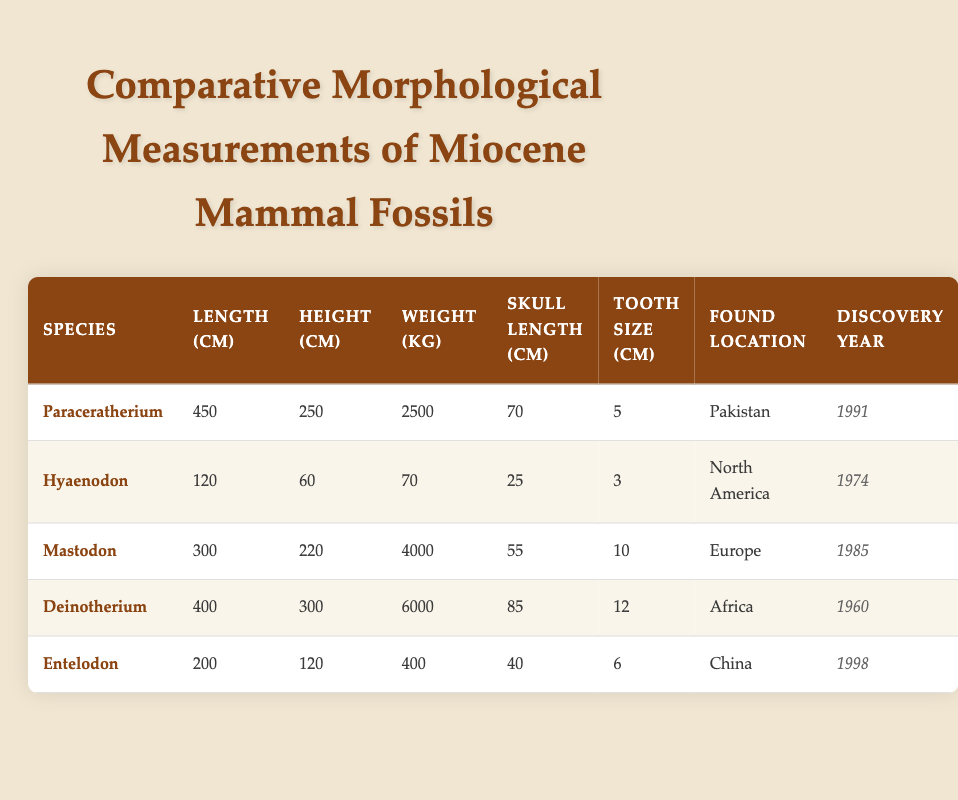What is the length of the Paraceratherium fossil? The length of the Paraceratherium fossil is directly found in the table under the "Length (cm)" column, which shows a value of 450 cm.
Answer: 450 cm Which species has the largest weight? To determine which species has the largest weight, I will compare the weight values in the "Weight (kg)" column: 2500 kg (Paraceratherium), 70 kg (Hyaenodon), 4000 kg (Mastodon), 6000 kg (Deinotherium), and 400 kg (Entelodon). The largest value is 6000 kg for Deinotherium.
Answer: Deinotherium Is the tooth size of Mastodon larger than that of Paraceratherium? I will check the values in the "Tooth Size (cm)" column for both species. Mastodon has a tooth size of 10 cm and Paraceratherium has a tooth size of 5 cm. Since 10 cm is greater than 5 cm, the statement is true.
Answer: Yes What is the average height of all the species listed in the table? I will first sum the heights in the "Height (cm)" column: 250 cm (Paraceratherium) + 60 cm (Hyaenodon) + 220 cm (Mastodon) + 300 cm (Deinotherium) + 120 cm (Entelodon) = 1050 cm. Then I will divide by the number of species, which is 5. Therefore, the average height is 1050 cm / 5 = 210 cm.
Answer: 210 cm Did the Hyaenodon fossil get discovered before the Mastodon fossil? The discovery years for Hyaenodon and Mastodon are found in the table. Hyaenodon has a discovery year of 1974 and Mastodon has a year of 1985. Since 1974 is less than 1985, this statement is true.
Answer: Yes What is the weight difference between the largest and smallest species? From the "Weight (kg)" column, the largest species is Deinotherium at 6000 kg, while the smallest is Hyaenodon at 70 kg. The difference is calculated by subtracting the smaller weight from the larger weight: 6000 kg - 70 kg = 5930 kg.
Answer: 5930 kg Which fossil was discovered in China? The table shows that Entelodon is the species found in China, under the "Found Location" column.
Answer: Entelodon What percentage of the total weight do the Hyaenodon and Entelodon contribute combined? The total weight of all species from the "Weight (kg)" column is 2500 kg + 70 kg + 4000 kg + 6000 kg + 400 kg = 9000 kg. Now, I'll sum the weights of Hyaenodon (70 kg) and Entelodon (400 kg) to get 470 kg. The percentage contributed is (470 kg / 9000 kg) * 100 = approximately 5.22%.
Answer: 5.22% 